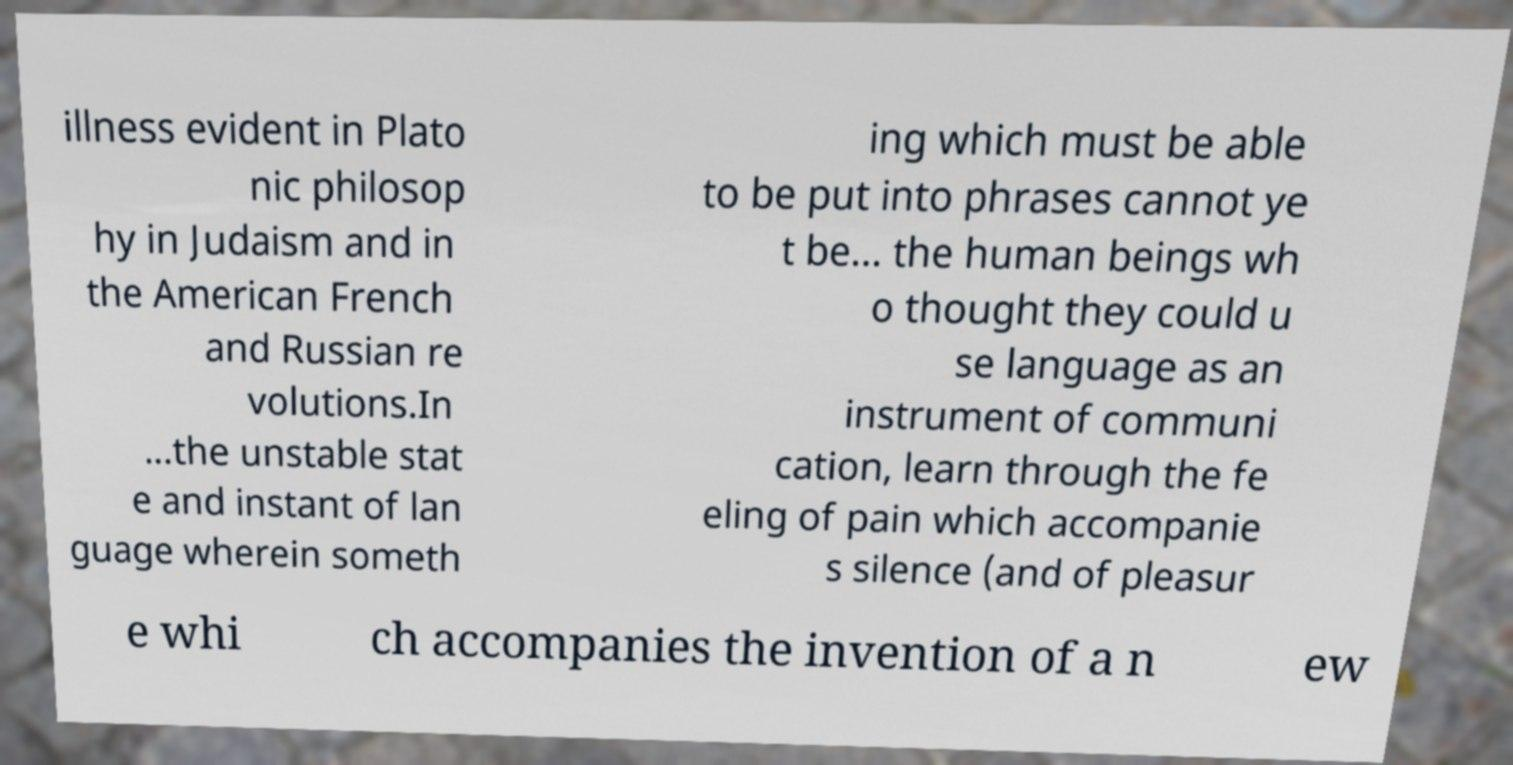There's text embedded in this image that I need extracted. Can you transcribe it verbatim? illness evident in Plato nic philosop hy in Judaism and in the American French and Russian re volutions.In ...the unstable stat e and instant of lan guage wherein someth ing which must be able to be put into phrases cannot ye t be… the human beings wh o thought they could u se language as an instrument of communi cation, learn through the fe eling of pain which accompanie s silence (and of pleasur e whi ch accompanies the invention of a n ew 